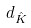Convert formula to latex. <formula><loc_0><loc_0><loc_500><loc_500>d _ { \hat { K } }</formula> 